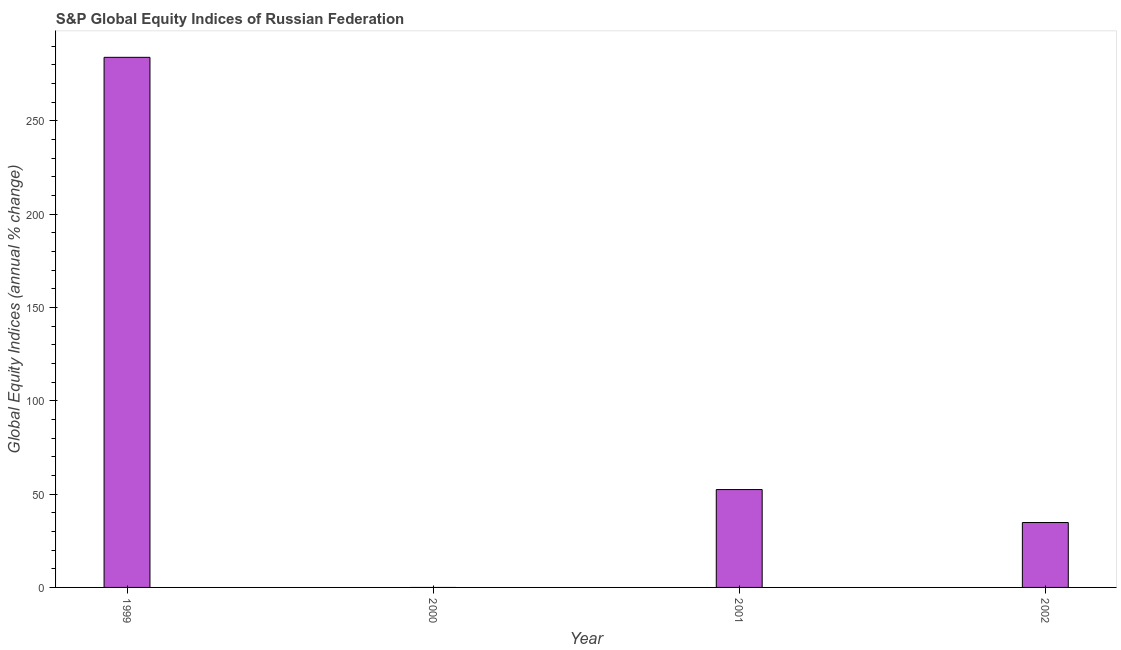Does the graph contain grids?
Provide a succinct answer. No. What is the title of the graph?
Ensure brevity in your answer.  S&P Global Equity Indices of Russian Federation. What is the label or title of the X-axis?
Your response must be concise. Year. What is the label or title of the Y-axis?
Make the answer very short. Global Equity Indices (annual % change). What is the s&p global equity indices in 1999?
Offer a very short reply. 284. Across all years, what is the maximum s&p global equity indices?
Keep it short and to the point. 284. Across all years, what is the minimum s&p global equity indices?
Provide a short and direct response. 0. What is the sum of the s&p global equity indices?
Offer a very short reply. 371.19. What is the difference between the s&p global equity indices in 1999 and 2002?
Provide a succinct answer. 249.23. What is the average s&p global equity indices per year?
Offer a terse response. 92.8. What is the median s&p global equity indices?
Ensure brevity in your answer.  43.6. What is the ratio of the s&p global equity indices in 2001 to that in 2002?
Your answer should be very brief. 1.51. What is the difference between the highest and the second highest s&p global equity indices?
Provide a short and direct response. 231.58. What is the difference between the highest and the lowest s&p global equity indices?
Provide a succinct answer. 284. How many years are there in the graph?
Your answer should be compact. 4. What is the Global Equity Indices (annual % change) of 1999?
Your response must be concise. 284. What is the Global Equity Indices (annual % change) in 2001?
Keep it short and to the point. 52.42. What is the Global Equity Indices (annual % change) in 2002?
Make the answer very short. 34.77. What is the difference between the Global Equity Indices (annual % change) in 1999 and 2001?
Ensure brevity in your answer.  231.58. What is the difference between the Global Equity Indices (annual % change) in 1999 and 2002?
Offer a terse response. 249.23. What is the difference between the Global Equity Indices (annual % change) in 2001 and 2002?
Your answer should be compact. 17.65. What is the ratio of the Global Equity Indices (annual % change) in 1999 to that in 2001?
Offer a very short reply. 5.42. What is the ratio of the Global Equity Indices (annual % change) in 1999 to that in 2002?
Provide a succinct answer. 8.17. What is the ratio of the Global Equity Indices (annual % change) in 2001 to that in 2002?
Provide a short and direct response. 1.51. 